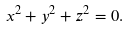Convert formula to latex. <formula><loc_0><loc_0><loc_500><loc_500>x ^ { 2 } + y ^ { 2 } + z ^ { 2 } = 0 .</formula> 